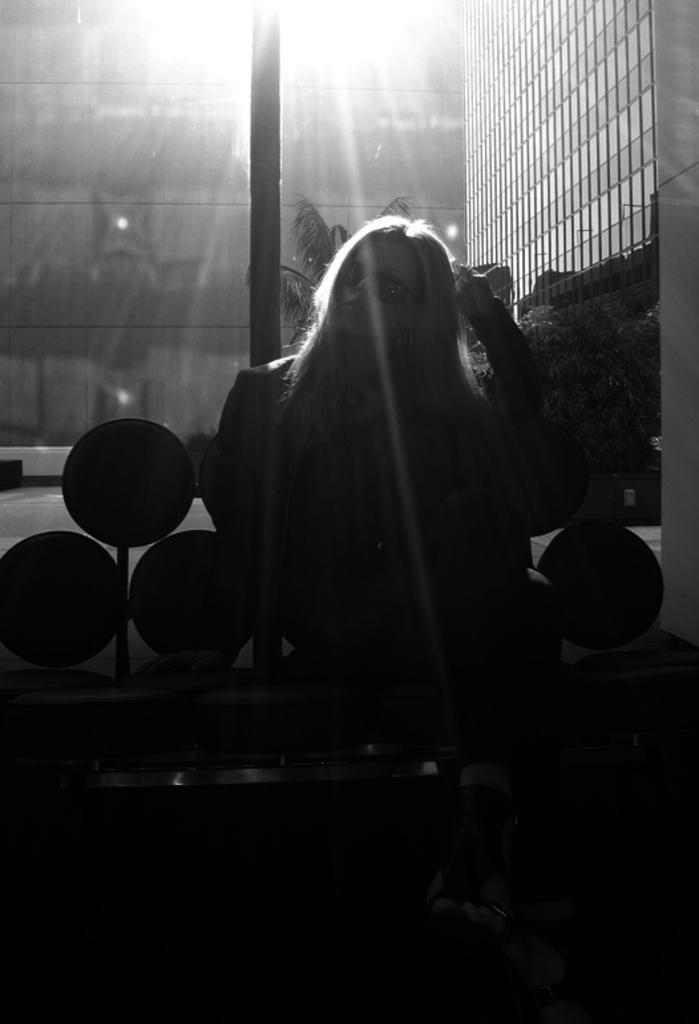Please provide a concise description of this image. In this image in the front there is a woman sitting on the bench. In the background there are buildings, there are plants and there are lights. 